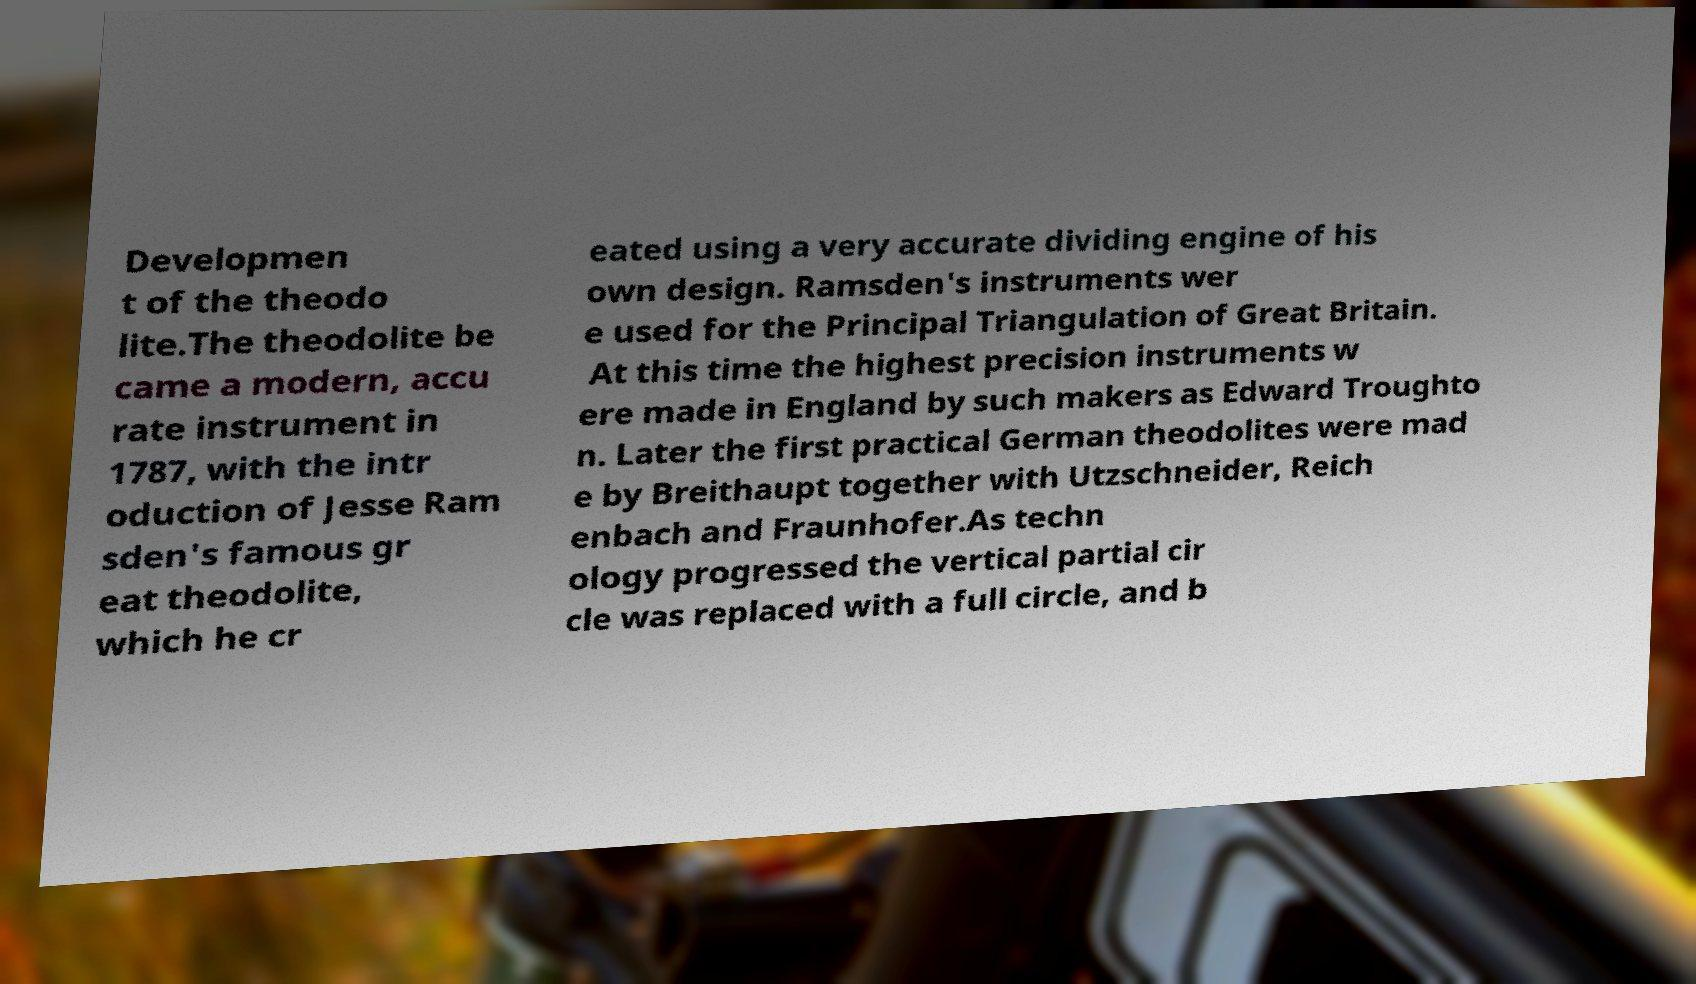There's text embedded in this image that I need extracted. Can you transcribe it verbatim? Developmen t of the theodo lite.The theodolite be came a modern, accu rate instrument in 1787, with the intr oduction of Jesse Ram sden's famous gr eat theodolite, which he cr eated using a very accurate dividing engine of his own design. Ramsden's instruments wer e used for the Principal Triangulation of Great Britain. At this time the highest precision instruments w ere made in England by such makers as Edward Troughto n. Later the first practical German theodolites were mad e by Breithaupt together with Utzschneider, Reich enbach and Fraunhofer.As techn ology progressed the vertical partial cir cle was replaced with a full circle, and b 